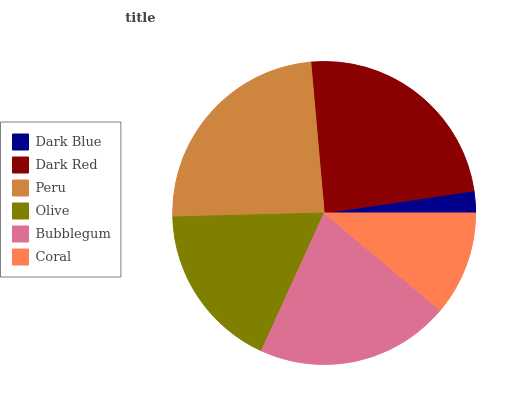Is Dark Blue the minimum?
Answer yes or no. Yes. Is Dark Red the maximum?
Answer yes or no. Yes. Is Peru the minimum?
Answer yes or no. No. Is Peru the maximum?
Answer yes or no. No. Is Dark Red greater than Peru?
Answer yes or no. Yes. Is Peru less than Dark Red?
Answer yes or no. Yes. Is Peru greater than Dark Red?
Answer yes or no. No. Is Dark Red less than Peru?
Answer yes or no. No. Is Bubblegum the high median?
Answer yes or no. Yes. Is Olive the low median?
Answer yes or no. Yes. Is Dark Blue the high median?
Answer yes or no. No. Is Dark Blue the low median?
Answer yes or no. No. 